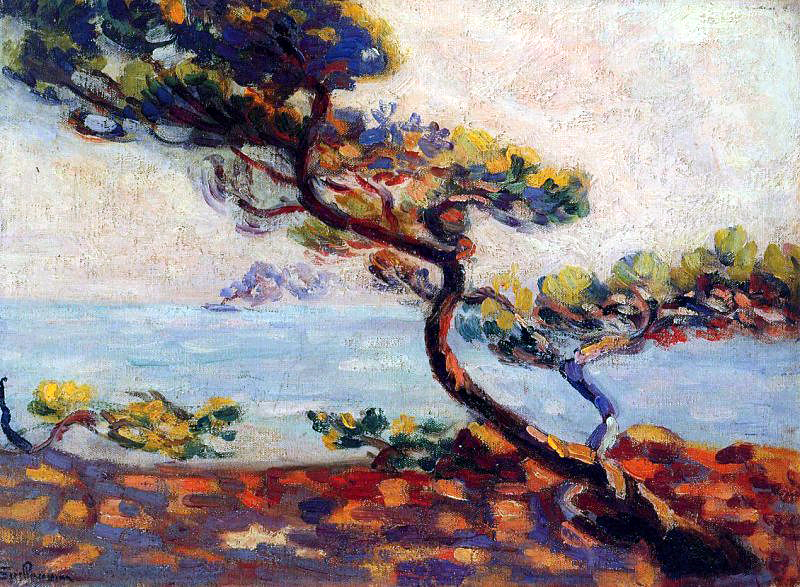What mood does the painting convey to you? The painting conveys a sense of tranquility and contemplation. The serene seascape and the quiet solitude of the twisted tree evoke a calm and reflective mood. The vibrant colors bring a touch of warmth and liveliness, suggesting a peaceful yet dynamic natural environment. 